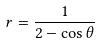Convert formula to latex. <formula><loc_0><loc_0><loc_500><loc_500>r = \frac { 1 } { 2 - \cos \theta }</formula> 